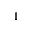<formula> <loc_0><loc_0><loc_500><loc_500>1</formula> 